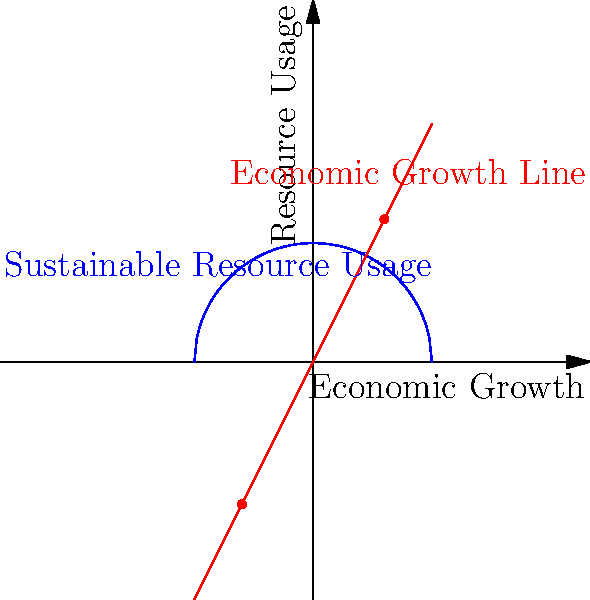In the graph above, the blue circle represents sustainable resource usage, while the red line represents economic growth. The circle has a radius of 10 units and is centered at the origin. The line has a slope of 2 and passes through the origin. At what points does the economic growth line intersect with the sustainable resource usage circle? What do these intersection points signify in terms of balancing economic development and conservation efforts? To find the intersection points, we need to solve the system of equations representing the circle and the line:

1) Circle equation: $x^2 + y^2 = 100$ (radius 10, centered at origin)
2) Line equation: $y = 2x$ (slope 2, passes through origin)

Substituting the line equation into the circle equation:

3) $x^2 + (2x)^2 = 100$
4) $x^2 + 4x^2 = 100$
5) $5x^2 = 100$
6) $x^2 = 20$
7) $x = \pm \sqrt{20} = \pm 2\sqrt{5}$

For $x = 2\sqrt{5}$:
8) $y = 2(2\sqrt{5}) = 4\sqrt{5}$

For $x = -2\sqrt{5}$:
9) $y = 2(-2\sqrt{5}) = -4\sqrt{5}$

Therefore, the intersection points are $(2\sqrt{5}, 4\sqrt{5})$ and $(-2\sqrt{5}, -4\sqrt{5})$.

These points signify:
- The upper intersection $(2\sqrt{5}, 4\sqrt{5})$ represents the maximum sustainable economic growth.
- The lower intersection $(-2\sqrt{5}, -4\sqrt{5})$ represents an unsustainable state of negative growth and resource depletion.
- Any point on the line between these intersections represents a sustainable balance between economic growth and resource usage.
- Points on the line outside the circle represent unsustainable economic growth that exceeds resource limits.
Answer: $(2\sqrt{5}, 4\sqrt{5})$ and $(-2\sqrt{5}, -4\sqrt{5})$; maximum sustainable growth and unsustainable negative growth, respectively. 